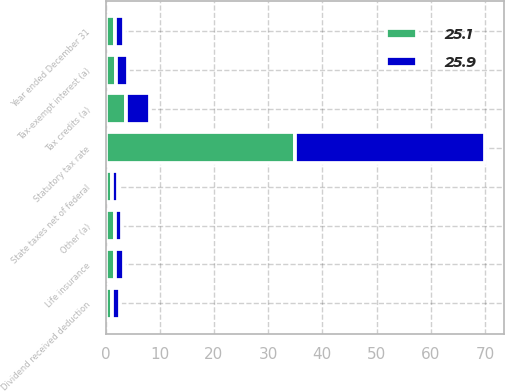Convert chart to OTSL. <chart><loc_0><loc_0><loc_500><loc_500><stacked_bar_chart><ecel><fcel>Year ended December 31<fcel>Statutory tax rate<fcel>State taxes net of federal<fcel>Tax-exempt interest (a)<fcel>Life insurance<fcel>Dividend received deduction<fcel>Tax credits (a)<fcel>Other (a)<nl><fcel>25.9<fcel>1.7<fcel>35<fcel>1.2<fcel>2.2<fcel>1.7<fcel>1.5<fcel>4.4<fcel>1.3<nl><fcel>25.1<fcel>1.7<fcel>35<fcel>1.1<fcel>1.9<fcel>1.7<fcel>1.2<fcel>3.7<fcel>1.7<nl></chart> 